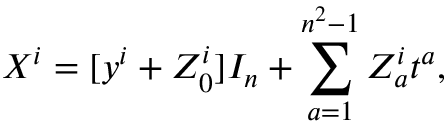<formula> <loc_0><loc_0><loc_500><loc_500>X ^ { i } = [ y ^ { i } + Z _ { 0 } ^ { i } ] I _ { n } + \sum _ { a = 1 } ^ { n ^ { 2 } - 1 } Z _ { a } ^ { i } t ^ { a } ,</formula> 